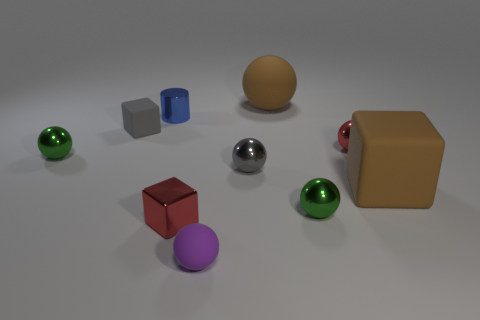Subtract all tiny matte blocks. How many blocks are left? 2 Subtract 1 spheres. How many spheres are left? 5 Add 1 metallic balls. How many metallic balls are left? 5 Add 8 blue balls. How many blue balls exist? 8 Subtract all purple spheres. How many spheres are left? 5 Subtract 0 cyan cubes. How many objects are left? 10 Subtract all cylinders. How many objects are left? 9 Subtract all cyan balls. Subtract all green cylinders. How many balls are left? 6 Subtract all yellow cubes. How many purple balls are left? 1 Subtract all purple spheres. Subtract all small spheres. How many objects are left? 4 